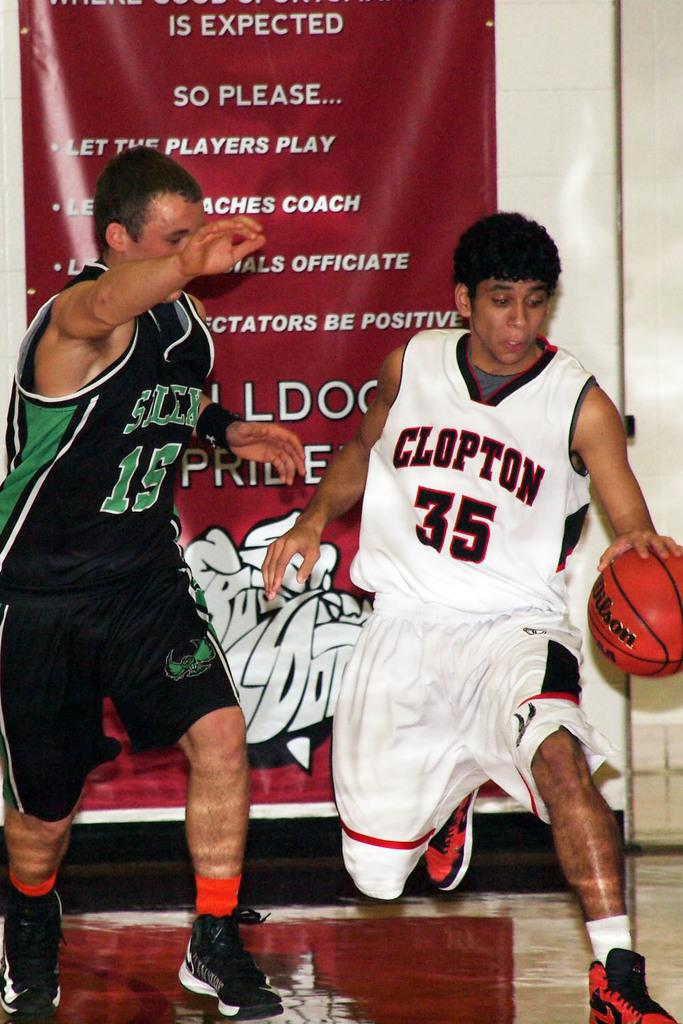<image>
Give a short and clear explanation of the subsequent image. A guy in a jersey with a 35 on it has the basketball. 